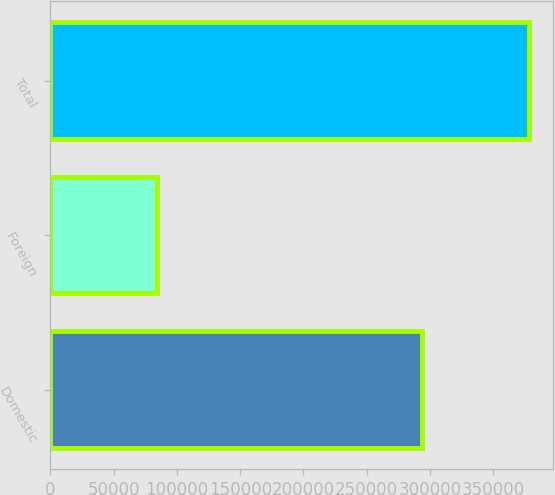Convert chart to OTSL. <chart><loc_0><loc_0><loc_500><loc_500><bar_chart><fcel>Domestic<fcel>Foreign<fcel>Total<nl><fcel>293851<fcel>84658<fcel>378509<nl></chart> 